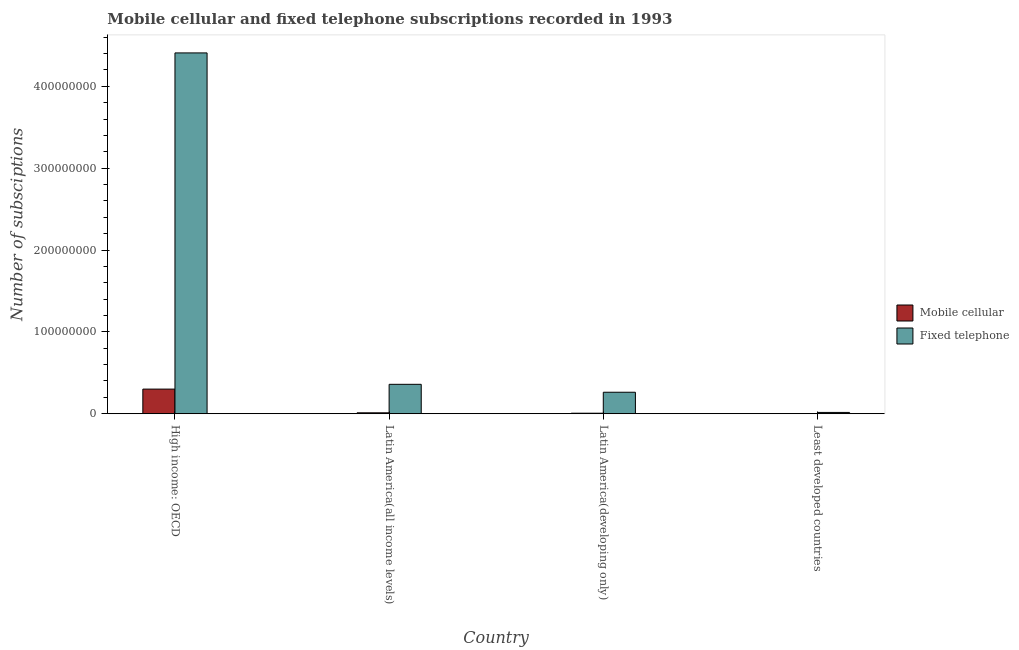How many bars are there on the 1st tick from the left?
Offer a terse response. 2. What is the label of the 2nd group of bars from the left?
Your answer should be compact. Latin America(all income levels). In how many cases, is the number of bars for a given country not equal to the number of legend labels?
Provide a succinct answer. 0. What is the number of mobile cellular subscriptions in High income: OECD?
Offer a terse response. 3.01e+07. Across all countries, what is the maximum number of mobile cellular subscriptions?
Offer a terse response. 3.01e+07. Across all countries, what is the minimum number of fixed telephone subscriptions?
Make the answer very short. 1.60e+06. In which country was the number of fixed telephone subscriptions maximum?
Ensure brevity in your answer.  High income: OECD. In which country was the number of mobile cellular subscriptions minimum?
Give a very brief answer. Least developed countries. What is the total number of mobile cellular subscriptions in the graph?
Provide a succinct answer. 3.19e+07. What is the difference between the number of mobile cellular subscriptions in Latin America(developing only) and that in Least developed countries?
Offer a terse response. 6.36e+05. What is the difference between the number of fixed telephone subscriptions in High income: OECD and the number of mobile cellular subscriptions in Latin America(developing only)?
Keep it short and to the point. 4.40e+08. What is the average number of mobile cellular subscriptions per country?
Provide a succinct answer. 7.97e+06. What is the difference between the number of mobile cellular subscriptions and number of fixed telephone subscriptions in Latin America(all income levels)?
Keep it short and to the point. -3.48e+07. What is the ratio of the number of fixed telephone subscriptions in Latin America(developing only) to that in Least developed countries?
Your answer should be compact. 16.44. What is the difference between the highest and the second highest number of fixed telephone subscriptions?
Your response must be concise. 4.05e+08. What is the difference between the highest and the lowest number of mobile cellular subscriptions?
Offer a very short reply. 3.01e+07. In how many countries, is the number of fixed telephone subscriptions greater than the average number of fixed telephone subscriptions taken over all countries?
Offer a terse response. 1. What does the 2nd bar from the left in Latin America(developing only) represents?
Offer a very short reply. Fixed telephone. What does the 2nd bar from the right in High income: OECD represents?
Offer a very short reply. Mobile cellular. How many bars are there?
Your answer should be compact. 8. Are all the bars in the graph horizontal?
Your response must be concise. No. How many countries are there in the graph?
Ensure brevity in your answer.  4. What is the difference between two consecutive major ticks on the Y-axis?
Make the answer very short. 1.00e+08. How many legend labels are there?
Provide a succinct answer. 2. How are the legend labels stacked?
Ensure brevity in your answer.  Vertical. What is the title of the graph?
Keep it short and to the point. Mobile cellular and fixed telephone subscriptions recorded in 1993. Does "Export" appear as one of the legend labels in the graph?
Your response must be concise. No. What is the label or title of the Y-axis?
Keep it short and to the point. Number of subsciptions. What is the Number of subsciptions in Mobile cellular in High income: OECD?
Your response must be concise. 3.01e+07. What is the Number of subsciptions of Fixed telephone in High income: OECD?
Keep it short and to the point. 4.41e+08. What is the Number of subsciptions in Mobile cellular in Latin America(all income levels)?
Offer a very short reply. 1.14e+06. What is the Number of subsciptions of Fixed telephone in Latin America(all income levels)?
Keep it short and to the point. 3.59e+07. What is the Number of subsciptions in Mobile cellular in Latin America(developing only)?
Provide a succinct answer. 6.49e+05. What is the Number of subsciptions in Fixed telephone in Latin America(developing only)?
Your response must be concise. 2.62e+07. What is the Number of subsciptions of Mobile cellular in Least developed countries?
Provide a short and direct response. 1.34e+04. What is the Number of subsciptions of Fixed telephone in Least developed countries?
Your response must be concise. 1.60e+06. Across all countries, what is the maximum Number of subsciptions in Mobile cellular?
Make the answer very short. 3.01e+07. Across all countries, what is the maximum Number of subsciptions of Fixed telephone?
Keep it short and to the point. 4.41e+08. Across all countries, what is the minimum Number of subsciptions in Mobile cellular?
Offer a very short reply. 1.34e+04. Across all countries, what is the minimum Number of subsciptions in Fixed telephone?
Offer a very short reply. 1.60e+06. What is the total Number of subsciptions of Mobile cellular in the graph?
Ensure brevity in your answer.  3.19e+07. What is the total Number of subsciptions of Fixed telephone in the graph?
Provide a short and direct response. 5.05e+08. What is the difference between the Number of subsciptions of Mobile cellular in High income: OECD and that in Latin America(all income levels)?
Your answer should be compact. 2.90e+07. What is the difference between the Number of subsciptions of Fixed telephone in High income: OECD and that in Latin America(all income levels)?
Provide a succinct answer. 4.05e+08. What is the difference between the Number of subsciptions in Mobile cellular in High income: OECD and that in Latin America(developing only)?
Offer a very short reply. 2.94e+07. What is the difference between the Number of subsciptions of Fixed telephone in High income: OECD and that in Latin America(developing only)?
Give a very brief answer. 4.14e+08. What is the difference between the Number of subsciptions in Mobile cellular in High income: OECD and that in Least developed countries?
Your response must be concise. 3.01e+07. What is the difference between the Number of subsciptions in Fixed telephone in High income: OECD and that in Least developed countries?
Provide a succinct answer. 4.39e+08. What is the difference between the Number of subsciptions in Mobile cellular in Latin America(all income levels) and that in Latin America(developing only)?
Your answer should be compact. 4.87e+05. What is the difference between the Number of subsciptions of Fixed telephone in Latin America(all income levels) and that in Latin America(developing only)?
Ensure brevity in your answer.  9.69e+06. What is the difference between the Number of subsciptions in Mobile cellular in Latin America(all income levels) and that in Least developed countries?
Your response must be concise. 1.12e+06. What is the difference between the Number of subsciptions in Fixed telephone in Latin America(all income levels) and that in Least developed countries?
Provide a short and direct response. 3.43e+07. What is the difference between the Number of subsciptions in Mobile cellular in Latin America(developing only) and that in Least developed countries?
Offer a terse response. 6.36e+05. What is the difference between the Number of subsciptions of Fixed telephone in Latin America(developing only) and that in Least developed countries?
Your answer should be compact. 2.47e+07. What is the difference between the Number of subsciptions in Mobile cellular in High income: OECD and the Number of subsciptions in Fixed telephone in Latin America(all income levels)?
Offer a terse response. -5.85e+06. What is the difference between the Number of subsciptions of Mobile cellular in High income: OECD and the Number of subsciptions of Fixed telephone in Latin America(developing only)?
Ensure brevity in your answer.  3.84e+06. What is the difference between the Number of subsciptions of Mobile cellular in High income: OECD and the Number of subsciptions of Fixed telephone in Least developed countries?
Offer a very short reply. 2.85e+07. What is the difference between the Number of subsciptions in Mobile cellular in Latin America(all income levels) and the Number of subsciptions in Fixed telephone in Latin America(developing only)?
Make the answer very short. -2.51e+07. What is the difference between the Number of subsciptions in Mobile cellular in Latin America(all income levels) and the Number of subsciptions in Fixed telephone in Least developed countries?
Provide a succinct answer. -4.61e+05. What is the difference between the Number of subsciptions in Mobile cellular in Latin America(developing only) and the Number of subsciptions in Fixed telephone in Least developed countries?
Your response must be concise. -9.47e+05. What is the average Number of subsciptions in Mobile cellular per country?
Ensure brevity in your answer.  7.97e+06. What is the average Number of subsciptions in Fixed telephone per country?
Offer a very short reply. 1.26e+08. What is the difference between the Number of subsciptions of Mobile cellular and Number of subsciptions of Fixed telephone in High income: OECD?
Offer a terse response. -4.11e+08. What is the difference between the Number of subsciptions in Mobile cellular and Number of subsciptions in Fixed telephone in Latin America(all income levels)?
Ensure brevity in your answer.  -3.48e+07. What is the difference between the Number of subsciptions of Mobile cellular and Number of subsciptions of Fixed telephone in Latin America(developing only)?
Make the answer very short. -2.56e+07. What is the difference between the Number of subsciptions of Mobile cellular and Number of subsciptions of Fixed telephone in Least developed countries?
Provide a short and direct response. -1.58e+06. What is the ratio of the Number of subsciptions of Mobile cellular in High income: OECD to that in Latin America(all income levels)?
Ensure brevity in your answer.  26.5. What is the ratio of the Number of subsciptions in Fixed telephone in High income: OECD to that in Latin America(all income levels)?
Keep it short and to the point. 12.27. What is the ratio of the Number of subsciptions in Mobile cellular in High income: OECD to that in Latin America(developing only)?
Your answer should be very brief. 46.37. What is the ratio of the Number of subsciptions of Fixed telephone in High income: OECD to that in Latin America(developing only)?
Ensure brevity in your answer.  16.79. What is the ratio of the Number of subsciptions in Mobile cellular in High income: OECD to that in Least developed countries?
Offer a terse response. 2242.87. What is the ratio of the Number of subsciptions in Fixed telephone in High income: OECD to that in Least developed countries?
Keep it short and to the point. 276.09. What is the ratio of the Number of subsciptions of Mobile cellular in Latin America(all income levels) to that in Latin America(developing only)?
Provide a succinct answer. 1.75. What is the ratio of the Number of subsciptions of Fixed telephone in Latin America(all income levels) to that in Latin America(developing only)?
Make the answer very short. 1.37. What is the ratio of the Number of subsciptions of Mobile cellular in Latin America(all income levels) to that in Least developed countries?
Give a very brief answer. 84.65. What is the ratio of the Number of subsciptions of Fixed telephone in Latin America(all income levels) to that in Least developed countries?
Your answer should be very brief. 22.51. What is the ratio of the Number of subsciptions of Mobile cellular in Latin America(developing only) to that in Least developed countries?
Your response must be concise. 48.37. What is the ratio of the Number of subsciptions in Fixed telephone in Latin America(developing only) to that in Least developed countries?
Your response must be concise. 16.44. What is the difference between the highest and the second highest Number of subsciptions of Mobile cellular?
Keep it short and to the point. 2.90e+07. What is the difference between the highest and the second highest Number of subsciptions of Fixed telephone?
Offer a terse response. 4.05e+08. What is the difference between the highest and the lowest Number of subsciptions in Mobile cellular?
Your response must be concise. 3.01e+07. What is the difference between the highest and the lowest Number of subsciptions of Fixed telephone?
Provide a succinct answer. 4.39e+08. 